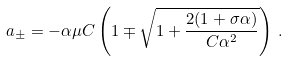<formula> <loc_0><loc_0><loc_500><loc_500>a _ { \pm } = - \alpha \mu C \left ( 1 \mp \sqrt { 1 + \frac { 2 ( 1 + \sigma \alpha ) } { C \alpha ^ { 2 } } } \right ) \, .</formula> 